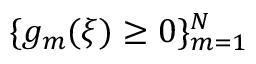<formula> <loc_0><loc_0><loc_500><loc_500>\{ g _ { m } ( \xi ) \geq 0 \} _ { m = 1 } ^ { N }</formula> 